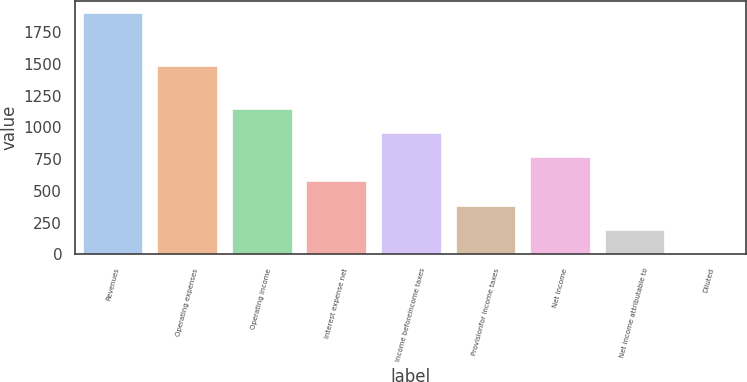<chart> <loc_0><loc_0><loc_500><loc_500><bar_chart><fcel>Revenues<fcel>Operating expenses<fcel>Operating income<fcel>Interest expense net<fcel>Income beforeincome taxes<fcel>Provisionfor income taxes<fcel>Net income<fcel>Net income attributable to<fcel>Diluted<nl><fcel>1903.9<fcel>1483.6<fcel>1143.93<fcel>573.93<fcel>953.93<fcel>383.93<fcel>763.93<fcel>193.93<fcel>3.93<nl></chart> 